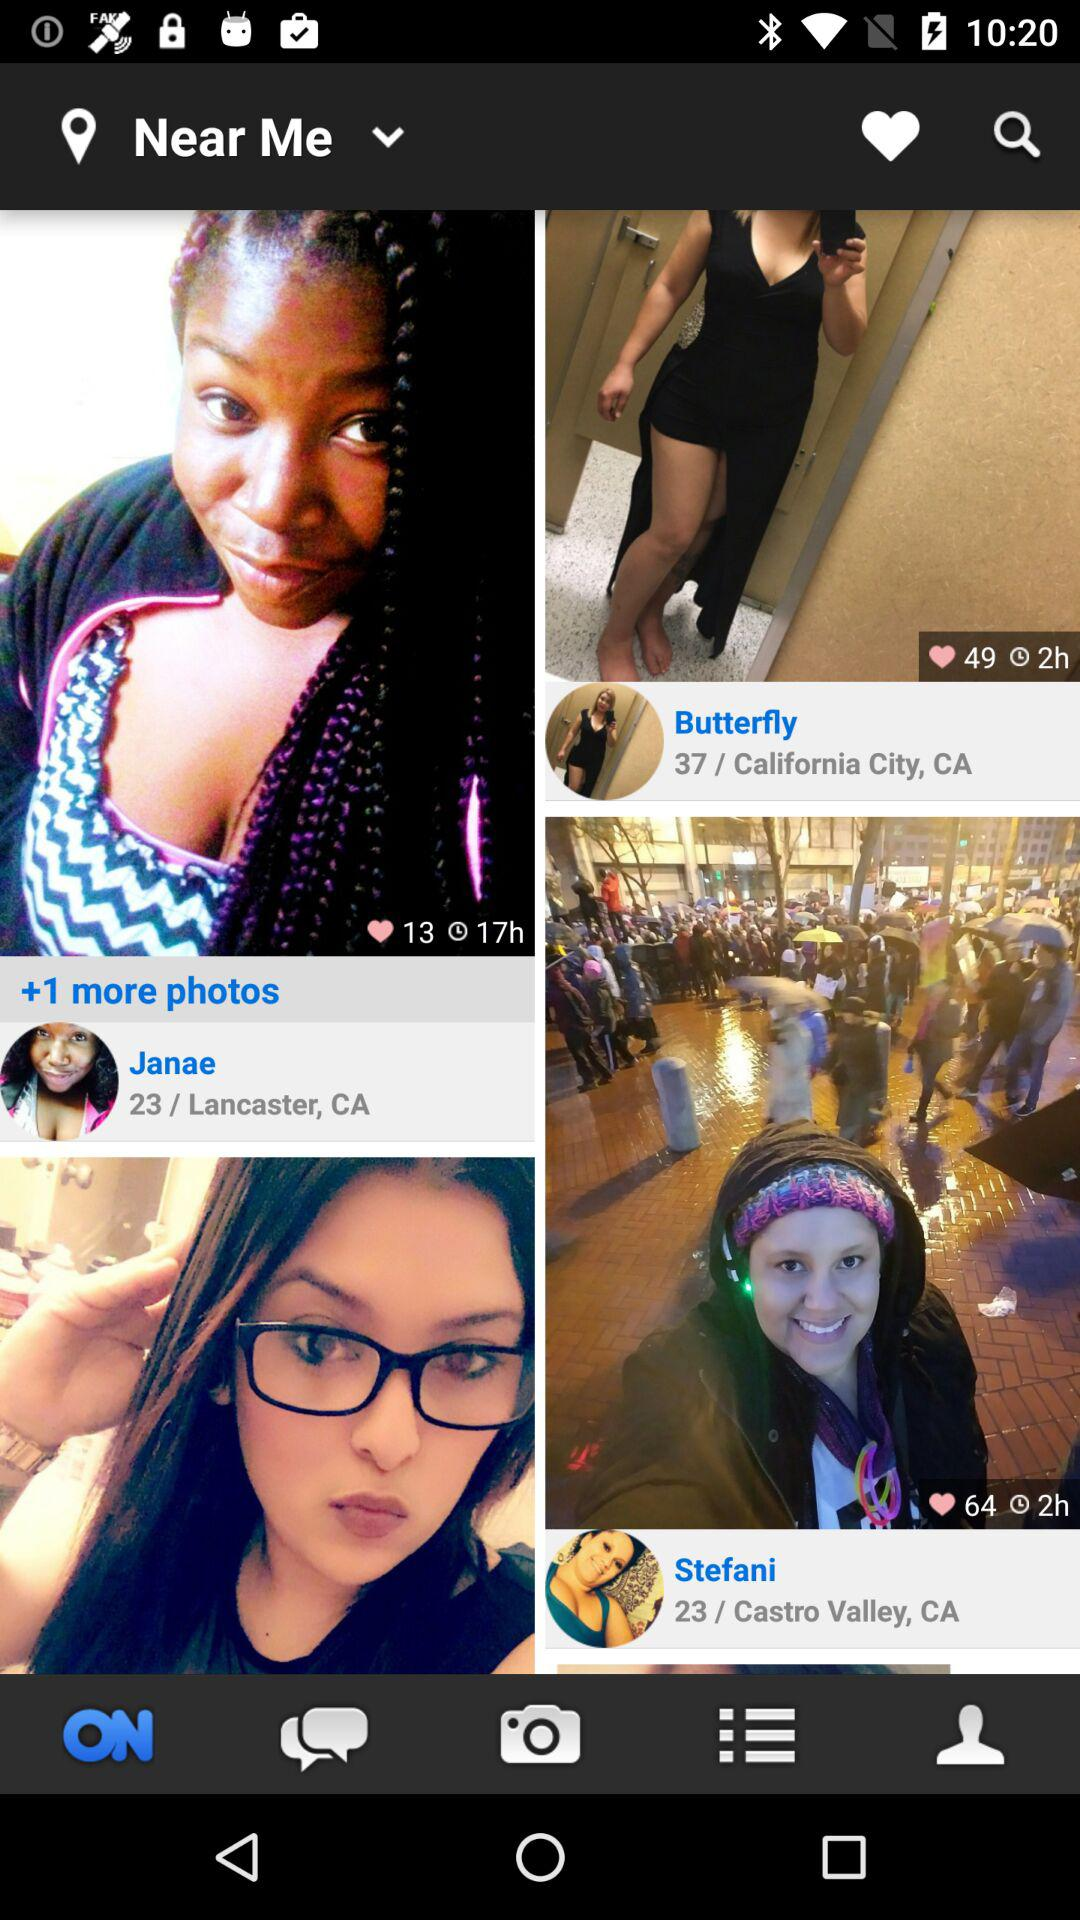When did Butterfly post the picture? Butterfly posted the picture 2 hours ago. 